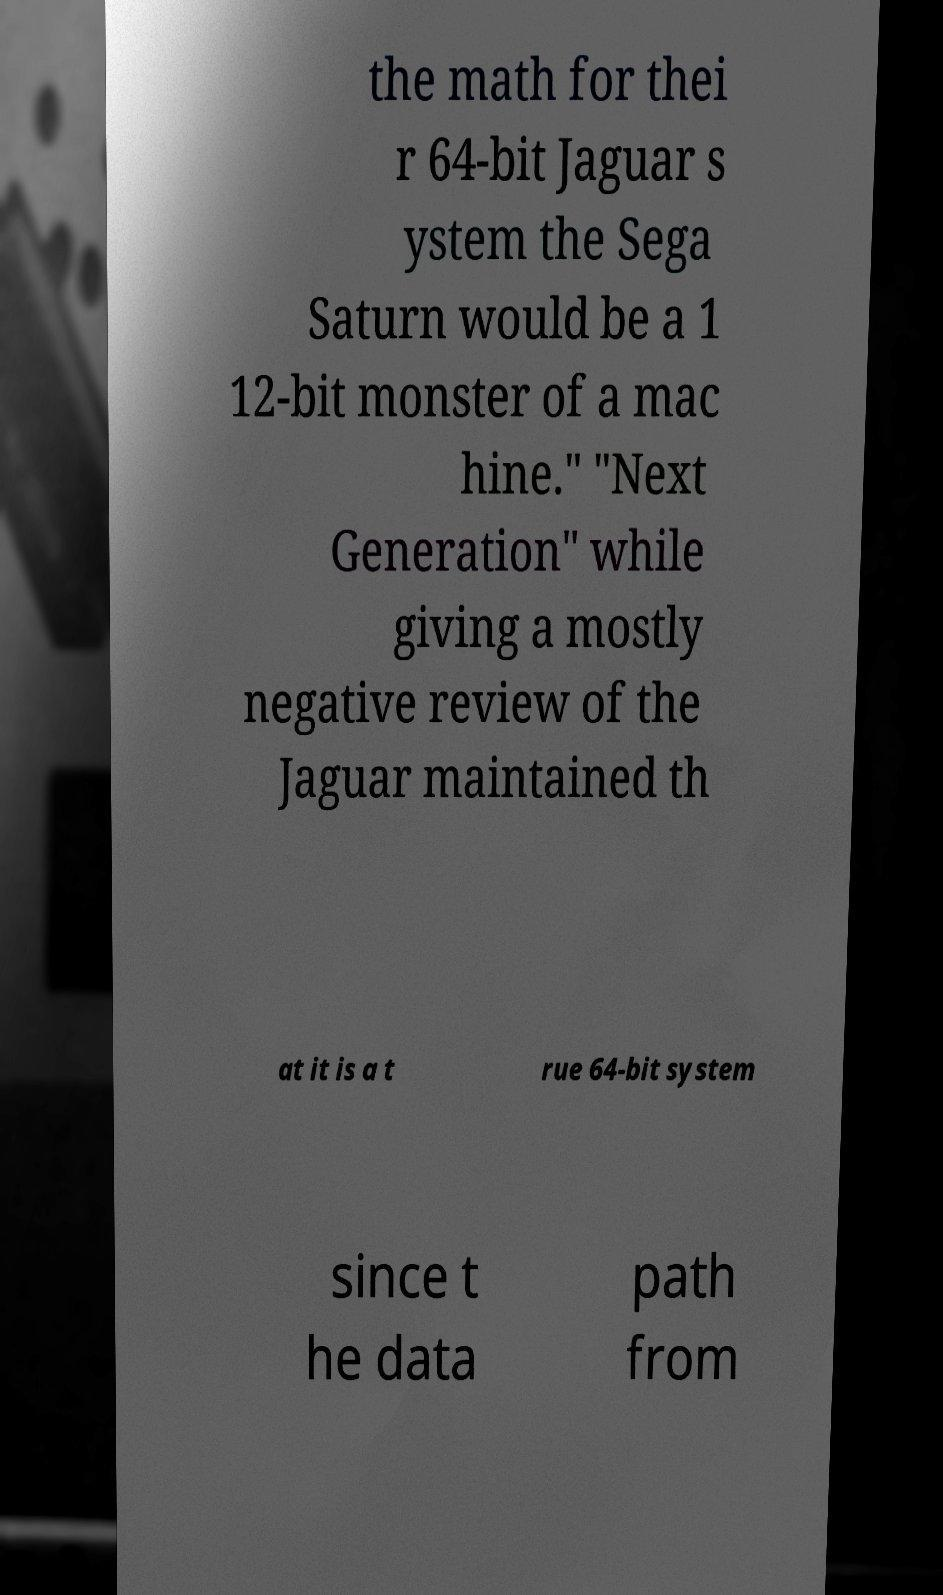What messages or text are displayed in this image? I need them in a readable, typed format. the math for thei r 64-bit Jaguar s ystem the Sega Saturn would be a 1 12-bit monster of a mac hine." "Next Generation" while giving a mostly negative review of the Jaguar maintained th at it is a t rue 64-bit system since t he data path from 